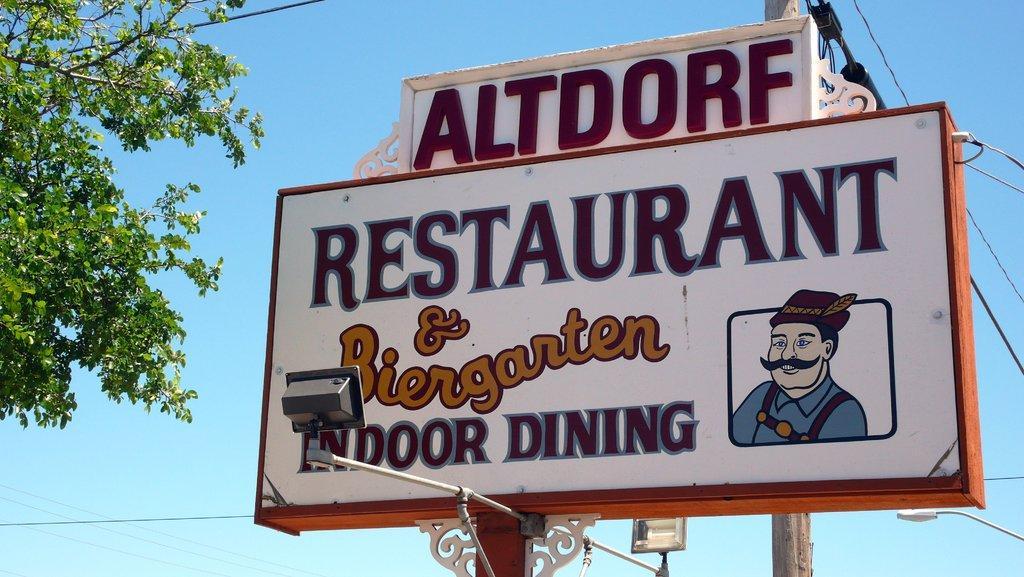Can you describe this image briefly? Here in this picture we can see a hoarding present on the pole over there and we can see lights present on either side of it and on the left side we can see a tree present over there and behind it we can see a light post present over there. 